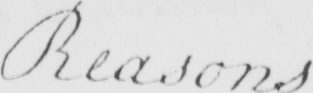What is written in this line of handwriting? Reasons 